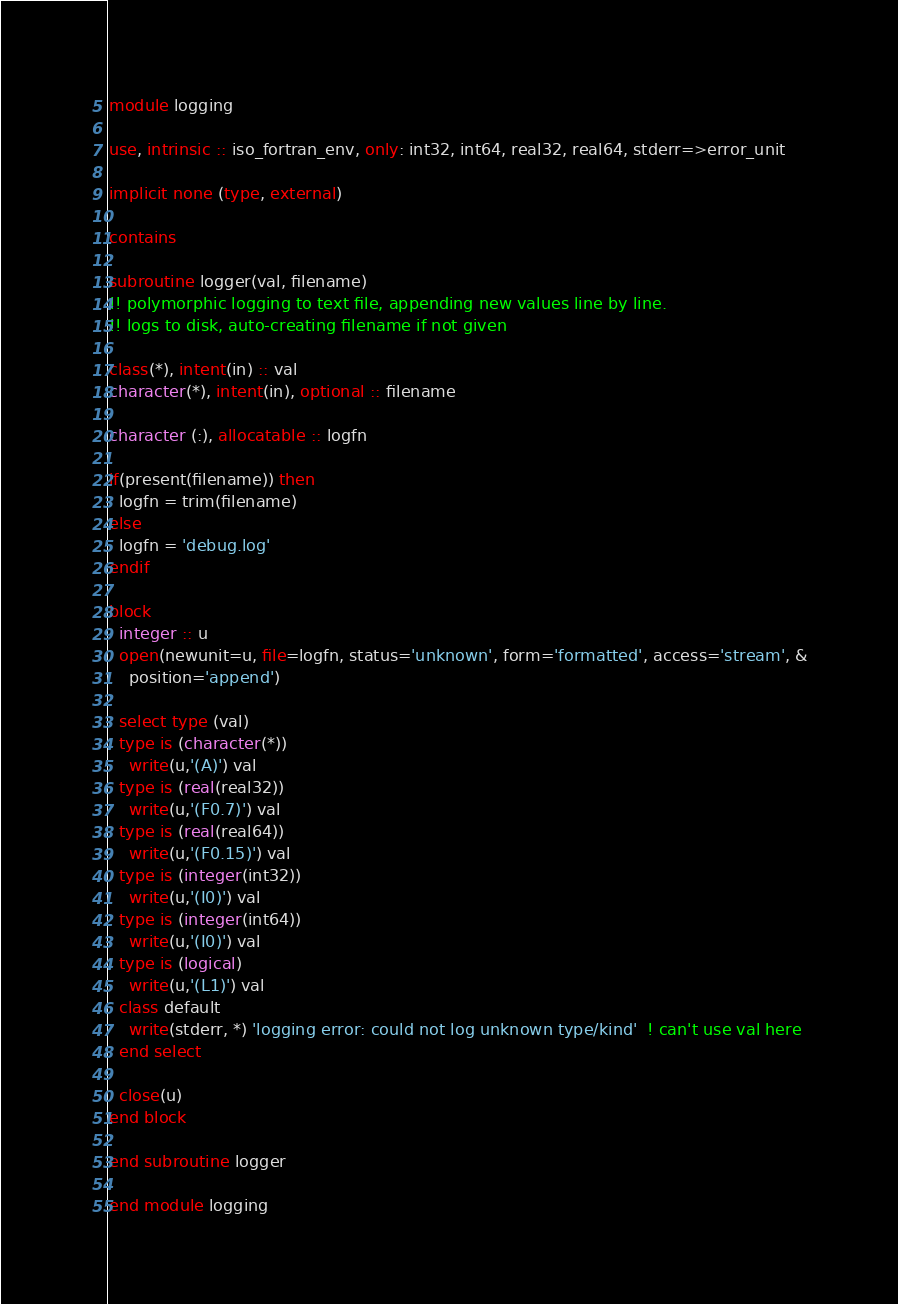Convert code to text. <code><loc_0><loc_0><loc_500><loc_500><_FORTRAN_>module logging

use, intrinsic :: iso_fortran_env, only: int32, int64, real32, real64, stderr=>error_unit

implicit none (type, external)

contains

subroutine logger(val, filename)
!! polymorphic logging to text file, appending new values line by line.
!! logs to disk, auto-creating filename if not given

class(*), intent(in) :: val
character(*), intent(in), optional :: filename

character (:), allocatable :: logfn

if(present(filename)) then
  logfn = trim(filename)
else
  logfn = 'debug.log'
endif

block
  integer :: u
  open(newunit=u, file=logfn, status='unknown', form='formatted', access='stream', &
    position='append')

  select type (val)
  type is (character(*))
    write(u,'(A)') val
  type is (real(real32))
    write(u,'(F0.7)') val
  type is (real(real64))
    write(u,'(F0.15)') val
  type is (integer(int32))
    write(u,'(I0)') val
  type is (integer(int64))
    write(u,'(I0)') val
  type is (logical)
    write(u,'(L1)') val
  class default
    write(stderr, *) 'logging error: could not log unknown type/kind'  ! can't use val here
  end select

  close(u)
end block

end subroutine logger

end module logging
</code> 